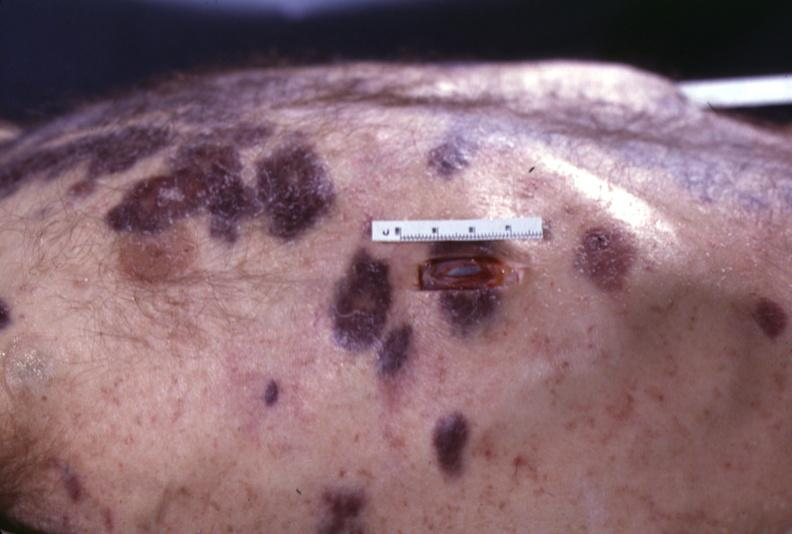does this image show skin, kaposi 's sarcoma?
Answer the question using a single word or phrase. Yes 